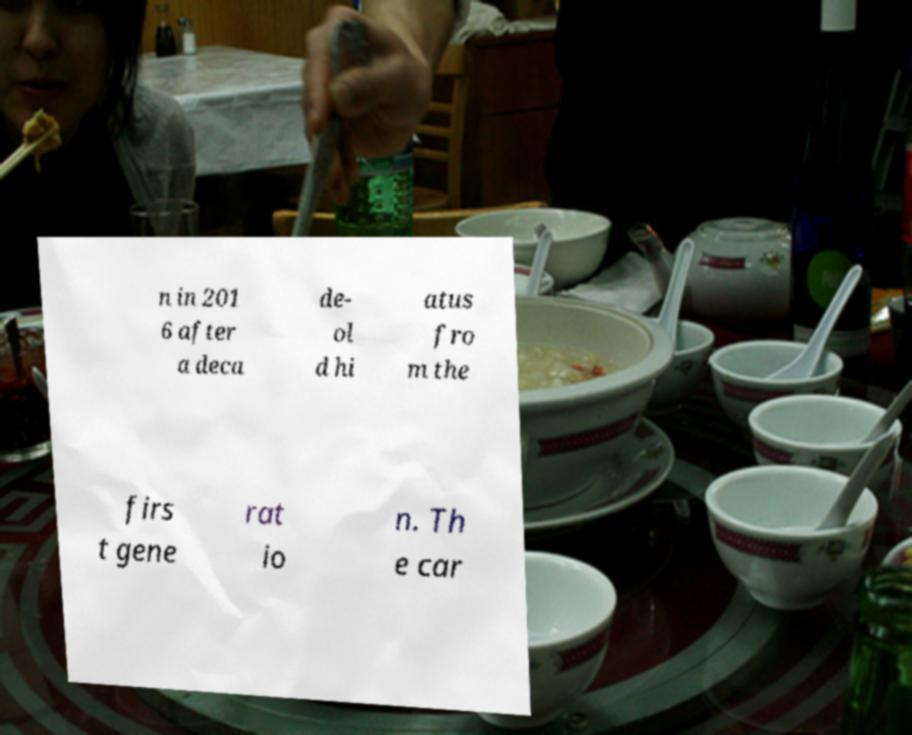What messages or text are displayed in this image? I need them in a readable, typed format. n in 201 6 after a deca de- ol d hi atus fro m the firs t gene rat io n. Th e car 